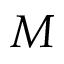<formula> <loc_0><loc_0><loc_500><loc_500>M</formula> 